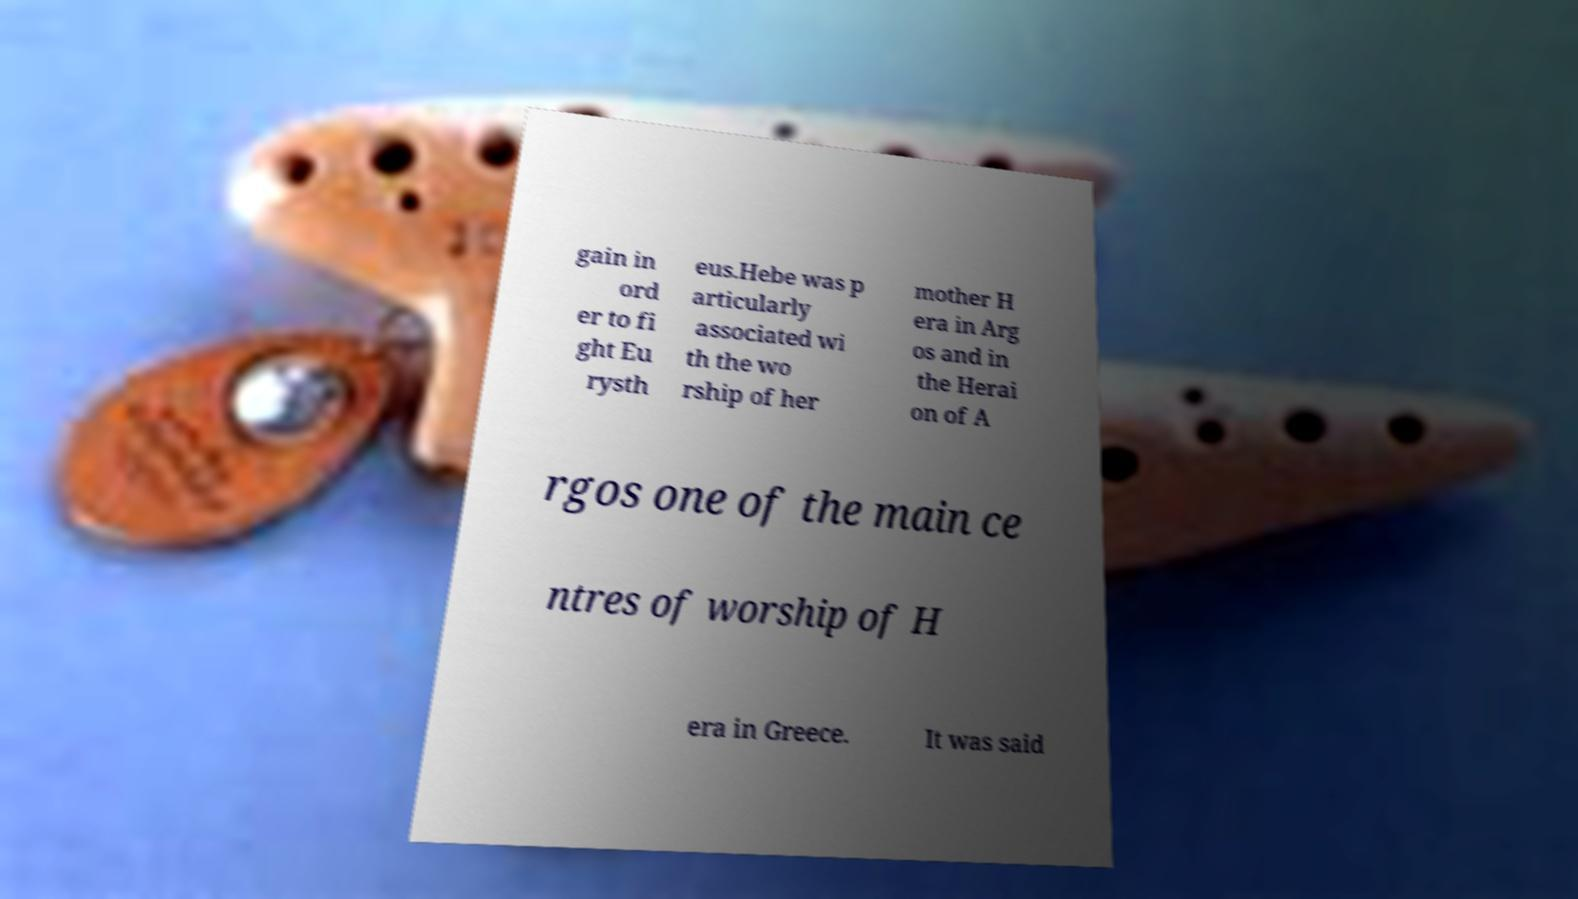For documentation purposes, I need the text within this image transcribed. Could you provide that? gain in ord er to fi ght Eu rysth eus.Hebe was p articularly associated wi th the wo rship of her mother H era in Arg os and in the Herai on of A rgos one of the main ce ntres of worship of H era in Greece. It was said 